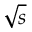<formula> <loc_0><loc_0><loc_500><loc_500>\sqrt { s }</formula> 